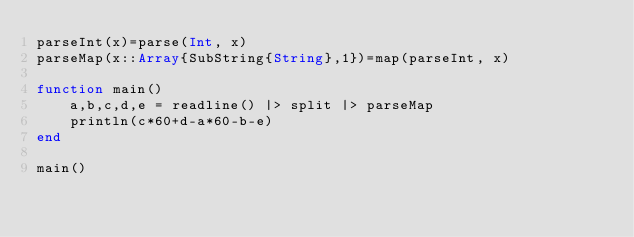<code> <loc_0><loc_0><loc_500><loc_500><_Julia_>parseInt(x)=parse(Int, x)
parseMap(x::Array{SubString{String},1})=map(parseInt, x)

function main()
	a,b,c,d,e = readline() |> split |> parseMap
	println(c*60+d-a*60-b-e)
end

main()</code> 